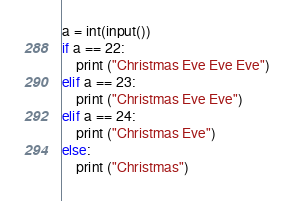<code> <loc_0><loc_0><loc_500><loc_500><_Python_>a = int(input())
if a == 22:
	print ("Christmas Eve Eve Eve")
elif a == 23:
	print ("Christmas Eve Eve")
elif a == 24:
	print ("Christmas Eve")
else:
	print ("Christmas")</code> 